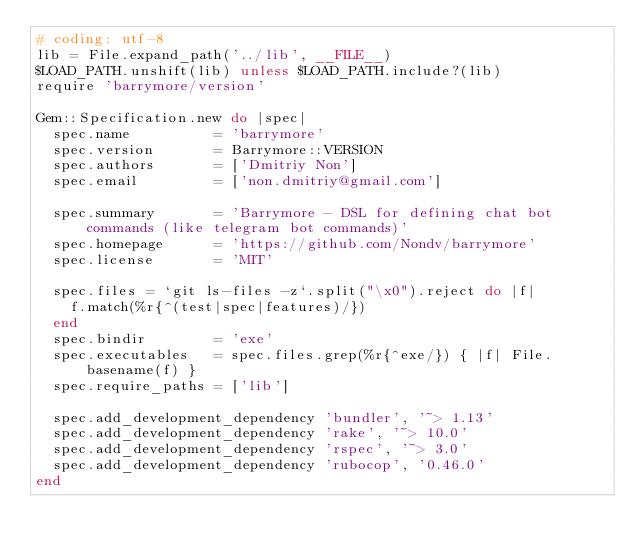<code> <loc_0><loc_0><loc_500><loc_500><_Ruby_># coding: utf-8
lib = File.expand_path('../lib', __FILE__)
$LOAD_PATH.unshift(lib) unless $LOAD_PATH.include?(lib)
require 'barrymore/version'

Gem::Specification.new do |spec|
  spec.name          = 'barrymore'
  spec.version       = Barrymore::VERSION
  spec.authors       = ['Dmitriy Non']
  spec.email         = ['non.dmitriy@gmail.com']

  spec.summary       = 'Barrymore - DSL for defining chat bot commands (like telegram bot commands)'
  spec.homepage      = 'https://github.com/Nondv/barrymore'
  spec.license       = 'MIT'

  spec.files = `git ls-files -z`.split("\x0").reject do |f|
    f.match(%r{^(test|spec|features)/})
  end
  spec.bindir        = 'exe'
  spec.executables   = spec.files.grep(%r{^exe/}) { |f| File.basename(f) }
  spec.require_paths = ['lib']

  spec.add_development_dependency 'bundler', '~> 1.13'
  spec.add_development_dependency 'rake', '~> 10.0'
  spec.add_development_dependency 'rspec', '~> 3.0'
  spec.add_development_dependency 'rubocop', '0.46.0'
end
</code> 